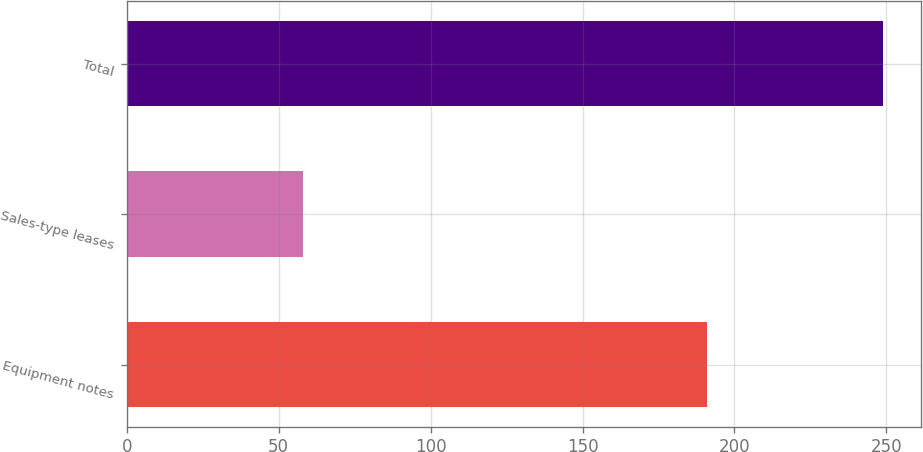Convert chart. <chart><loc_0><loc_0><loc_500><loc_500><bar_chart><fcel>Equipment notes<fcel>Sales-type leases<fcel>Total<nl><fcel>191<fcel>58<fcel>249<nl></chart> 